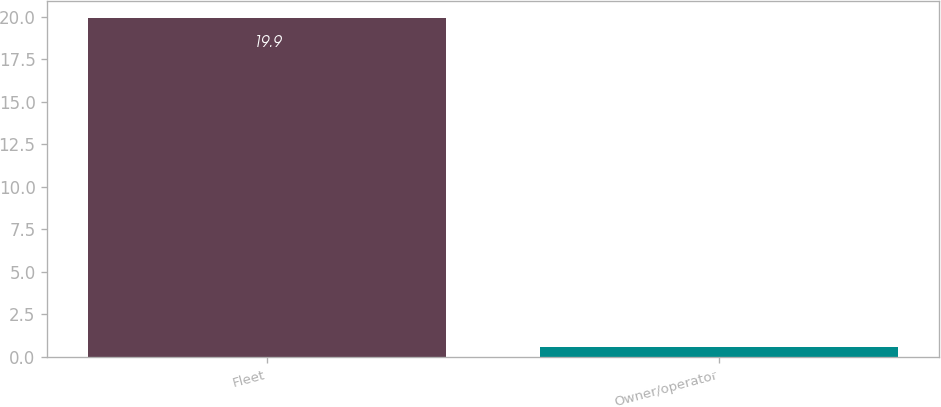<chart> <loc_0><loc_0><loc_500><loc_500><bar_chart><fcel>Fleet<fcel>Owner/operator<nl><fcel>19.9<fcel>0.6<nl></chart> 